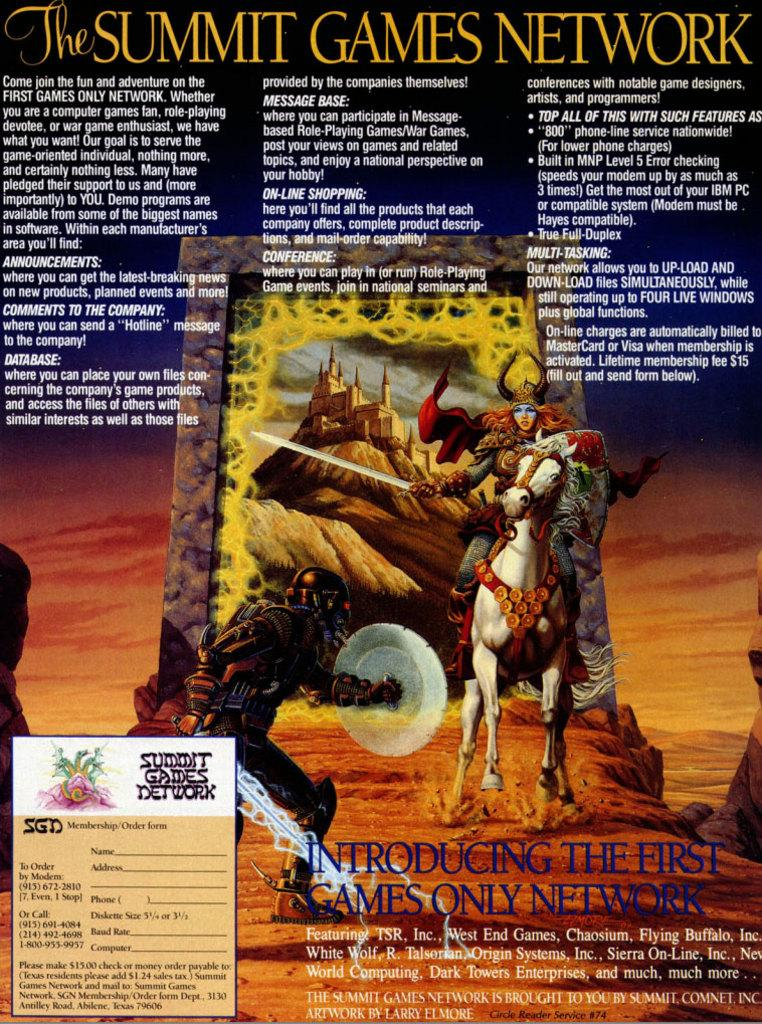What is the main activity happening in the image? There is a person riding a horse and another person fighting on the land in the image. Can you describe the two main subjects in the image? One person is riding a horse, while the other person is engaged in a fight on the ground. What type of border can be seen surrounding the area where the fight is taking place? There is no border visible in the image; it only shows a person riding a horse and another person fighting on the land. 